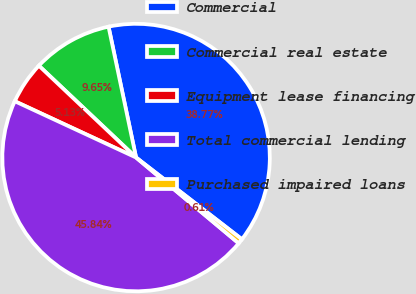Convert chart to OTSL. <chart><loc_0><loc_0><loc_500><loc_500><pie_chart><fcel>Commercial<fcel>Commercial real estate<fcel>Equipment lease financing<fcel>Total commercial lending<fcel>Purchased impaired loans<nl><fcel>38.77%<fcel>9.65%<fcel>5.13%<fcel>45.84%<fcel>0.61%<nl></chart> 